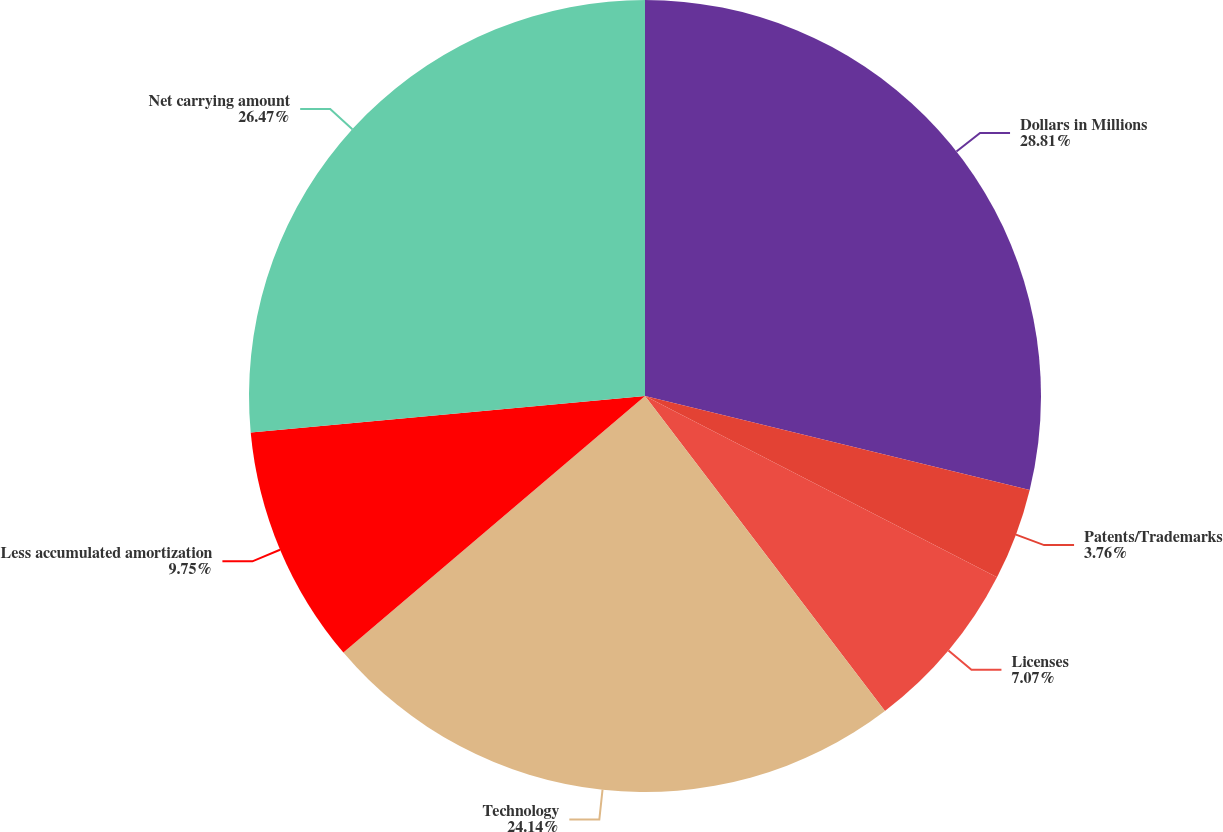Convert chart. <chart><loc_0><loc_0><loc_500><loc_500><pie_chart><fcel>Dollars in Millions<fcel>Patents/Trademarks<fcel>Licenses<fcel>Technology<fcel>Less accumulated amortization<fcel>Net carrying amount<nl><fcel>28.81%<fcel>3.76%<fcel>7.07%<fcel>24.14%<fcel>9.75%<fcel>26.47%<nl></chart> 